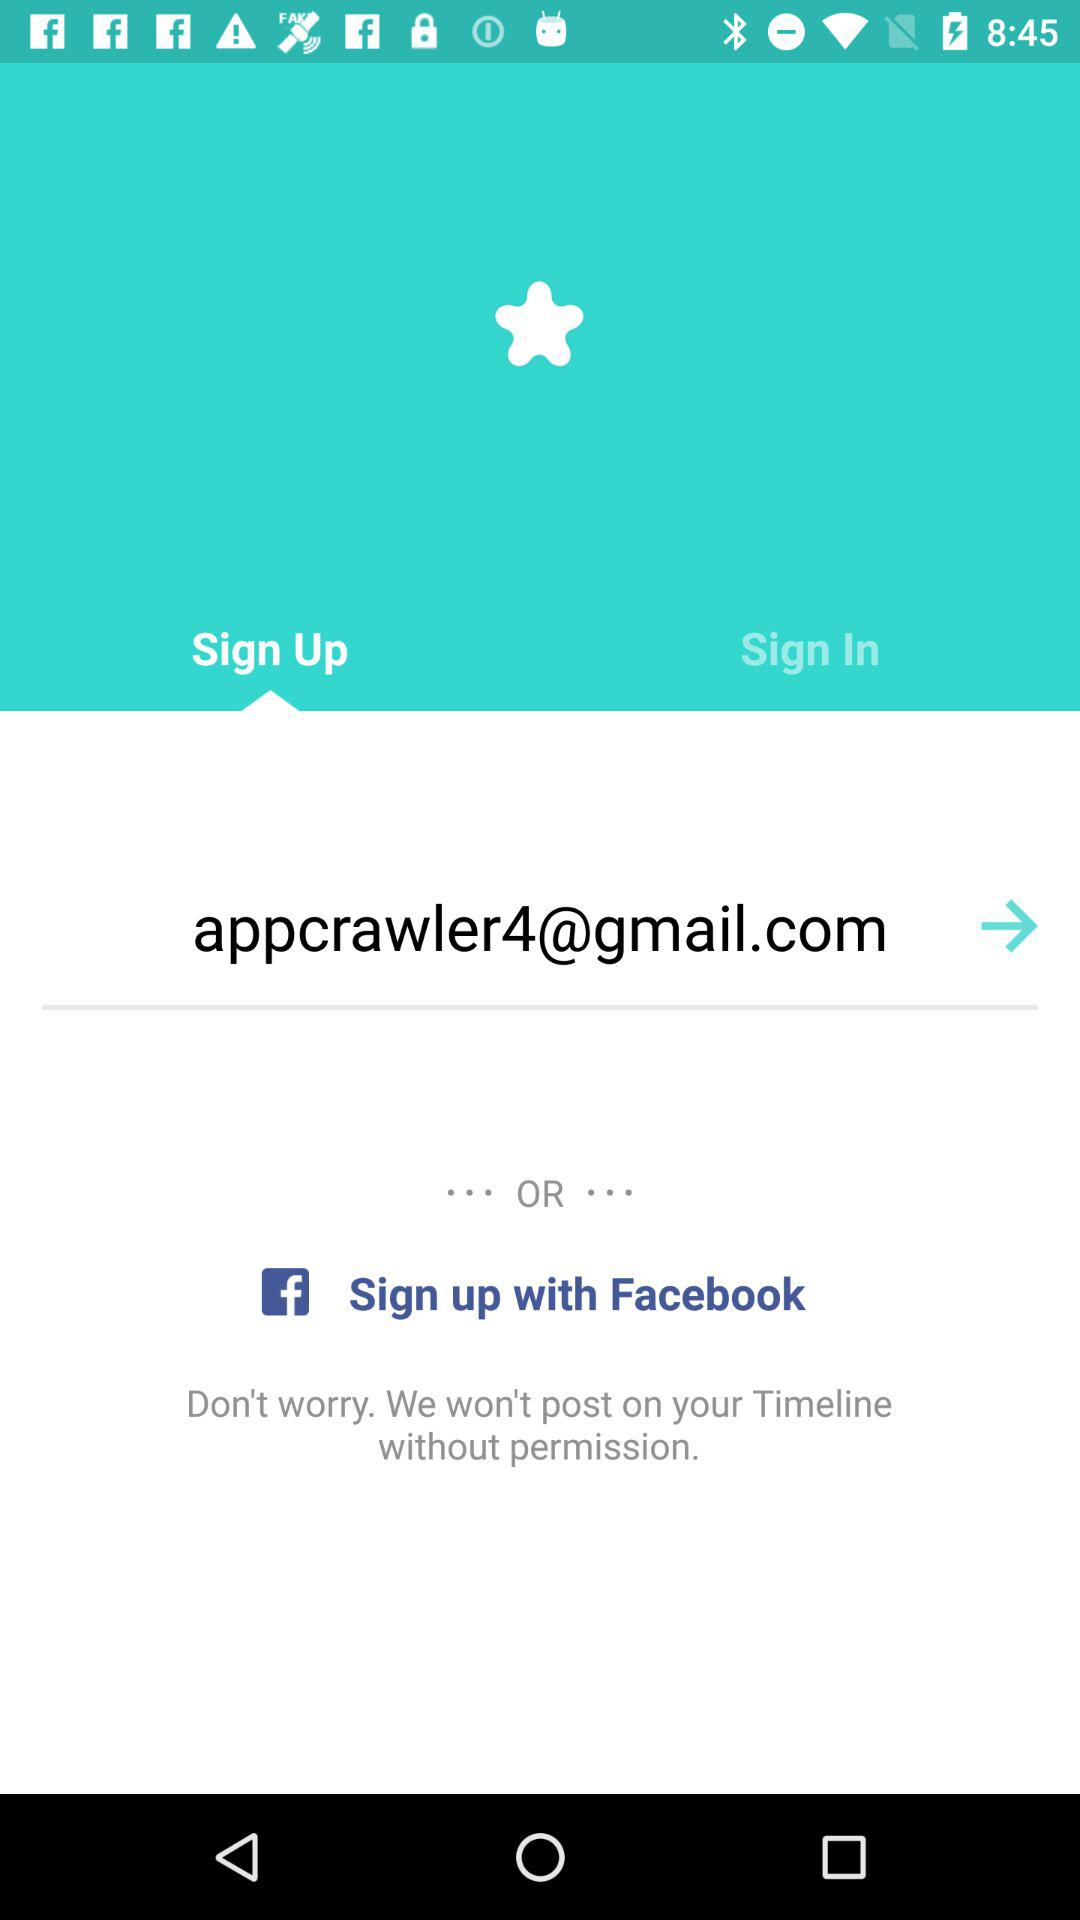Through which application can we sign in?
When the provided information is insufficient, respond with <no answer>. <no answer> 